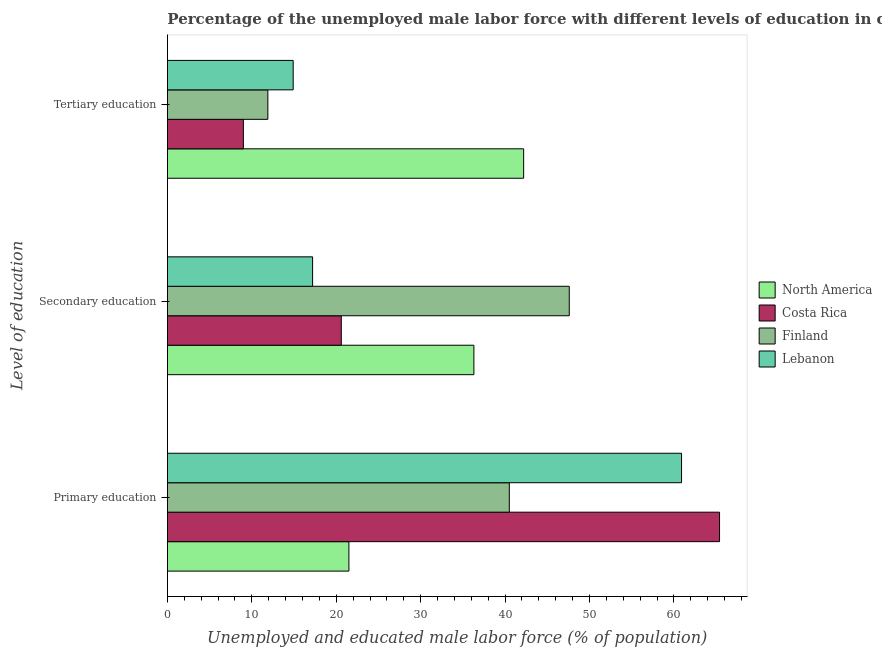Are the number of bars per tick equal to the number of legend labels?
Provide a succinct answer. Yes. Are the number of bars on each tick of the Y-axis equal?
Your response must be concise. Yes. What is the label of the 2nd group of bars from the top?
Provide a short and direct response. Secondary education. What is the percentage of male labor force who received primary education in Costa Rica?
Make the answer very short. 65.4. Across all countries, what is the maximum percentage of male labor force who received secondary education?
Offer a very short reply. 47.6. Across all countries, what is the minimum percentage of male labor force who received primary education?
Keep it short and to the point. 21.5. In which country was the percentage of male labor force who received secondary education maximum?
Give a very brief answer. Finland. In which country was the percentage of male labor force who received primary education minimum?
Offer a terse response. North America. What is the total percentage of male labor force who received secondary education in the graph?
Your answer should be very brief. 121.7. What is the difference between the percentage of male labor force who received tertiary education in North America and that in Costa Rica?
Your response must be concise. 33.2. What is the difference between the percentage of male labor force who received secondary education in Costa Rica and the percentage of male labor force who received primary education in North America?
Offer a terse response. -0.9. What is the average percentage of male labor force who received secondary education per country?
Keep it short and to the point. 30.43. What is the difference between the percentage of male labor force who received primary education and percentage of male labor force who received secondary education in Costa Rica?
Keep it short and to the point. 44.8. In how many countries, is the percentage of male labor force who received primary education greater than 60 %?
Provide a succinct answer. 2. What is the ratio of the percentage of male labor force who received tertiary education in North America to that in Finland?
Keep it short and to the point. 3.55. Is the percentage of male labor force who received tertiary education in Costa Rica less than that in Finland?
Your answer should be very brief. Yes. What is the difference between the highest and the second highest percentage of male labor force who received secondary education?
Ensure brevity in your answer.  11.3. What is the difference between the highest and the lowest percentage of male labor force who received primary education?
Offer a terse response. 43.9. In how many countries, is the percentage of male labor force who received secondary education greater than the average percentage of male labor force who received secondary education taken over all countries?
Give a very brief answer. 2. What does the 3rd bar from the top in Primary education represents?
Offer a terse response. Costa Rica. What does the 4th bar from the bottom in Primary education represents?
Offer a very short reply. Lebanon. Are all the bars in the graph horizontal?
Your answer should be compact. Yes. What is the difference between two consecutive major ticks on the X-axis?
Offer a very short reply. 10. Are the values on the major ticks of X-axis written in scientific E-notation?
Your response must be concise. No. Does the graph contain any zero values?
Provide a short and direct response. No. Does the graph contain grids?
Give a very brief answer. No. Where does the legend appear in the graph?
Your answer should be compact. Center right. How are the legend labels stacked?
Ensure brevity in your answer.  Vertical. What is the title of the graph?
Offer a very short reply. Percentage of the unemployed male labor force with different levels of education in countries. What is the label or title of the X-axis?
Make the answer very short. Unemployed and educated male labor force (% of population). What is the label or title of the Y-axis?
Provide a short and direct response. Level of education. What is the Unemployed and educated male labor force (% of population) in North America in Primary education?
Your answer should be compact. 21.5. What is the Unemployed and educated male labor force (% of population) of Costa Rica in Primary education?
Make the answer very short. 65.4. What is the Unemployed and educated male labor force (% of population) in Finland in Primary education?
Give a very brief answer. 40.5. What is the Unemployed and educated male labor force (% of population) of Lebanon in Primary education?
Your response must be concise. 60.9. What is the Unemployed and educated male labor force (% of population) in North America in Secondary education?
Offer a very short reply. 36.3. What is the Unemployed and educated male labor force (% of population) in Costa Rica in Secondary education?
Offer a very short reply. 20.6. What is the Unemployed and educated male labor force (% of population) of Finland in Secondary education?
Provide a succinct answer. 47.6. What is the Unemployed and educated male labor force (% of population) in Lebanon in Secondary education?
Ensure brevity in your answer.  17.2. What is the Unemployed and educated male labor force (% of population) in North America in Tertiary education?
Ensure brevity in your answer.  42.2. What is the Unemployed and educated male labor force (% of population) of Finland in Tertiary education?
Your answer should be very brief. 11.9. What is the Unemployed and educated male labor force (% of population) of Lebanon in Tertiary education?
Ensure brevity in your answer.  14.9. Across all Level of education, what is the maximum Unemployed and educated male labor force (% of population) in North America?
Your response must be concise. 42.2. Across all Level of education, what is the maximum Unemployed and educated male labor force (% of population) of Costa Rica?
Your answer should be compact. 65.4. Across all Level of education, what is the maximum Unemployed and educated male labor force (% of population) in Finland?
Make the answer very short. 47.6. Across all Level of education, what is the maximum Unemployed and educated male labor force (% of population) of Lebanon?
Provide a succinct answer. 60.9. Across all Level of education, what is the minimum Unemployed and educated male labor force (% of population) of North America?
Offer a very short reply. 21.5. Across all Level of education, what is the minimum Unemployed and educated male labor force (% of population) of Finland?
Give a very brief answer. 11.9. Across all Level of education, what is the minimum Unemployed and educated male labor force (% of population) in Lebanon?
Keep it short and to the point. 14.9. What is the total Unemployed and educated male labor force (% of population) in North America in the graph?
Keep it short and to the point. 100. What is the total Unemployed and educated male labor force (% of population) of Lebanon in the graph?
Provide a succinct answer. 93. What is the difference between the Unemployed and educated male labor force (% of population) in North America in Primary education and that in Secondary education?
Your answer should be compact. -14.8. What is the difference between the Unemployed and educated male labor force (% of population) in Costa Rica in Primary education and that in Secondary education?
Offer a terse response. 44.8. What is the difference between the Unemployed and educated male labor force (% of population) in Finland in Primary education and that in Secondary education?
Provide a short and direct response. -7.1. What is the difference between the Unemployed and educated male labor force (% of population) in Lebanon in Primary education and that in Secondary education?
Ensure brevity in your answer.  43.7. What is the difference between the Unemployed and educated male labor force (% of population) in North America in Primary education and that in Tertiary education?
Ensure brevity in your answer.  -20.7. What is the difference between the Unemployed and educated male labor force (% of population) of Costa Rica in Primary education and that in Tertiary education?
Provide a short and direct response. 56.4. What is the difference between the Unemployed and educated male labor force (% of population) of Finland in Primary education and that in Tertiary education?
Offer a very short reply. 28.6. What is the difference between the Unemployed and educated male labor force (% of population) of North America in Secondary education and that in Tertiary education?
Make the answer very short. -5.89. What is the difference between the Unemployed and educated male labor force (% of population) of Finland in Secondary education and that in Tertiary education?
Offer a very short reply. 35.7. What is the difference between the Unemployed and educated male labor force (% of population) of North America in Primary education and the Unemployed and educated male labor force (% of population) of Costa Rica in Secondary education?
Keep it short and to the point. 0.9. What is the difference between the Unemployed and educated male labor force (% of population) of North America in Primary education and the Unemployed and educated male labor force (% of population) of Finland in Secondary education?
Offer a very short reply. -26.1. What is the difference between the Unemployed and educated male labor force (% of population) of North America in Primary education and the Unemployed and educated male labor force (% of population) of Lebanon in Secondary education?
Ensure brevity in your answer.  4.3. What is the difference between the Unemployed and educated male labor force (% of population) of Costa Rica in Primary education and the Unemployed and educated male labor force (% of population) of Finland in Secondary education?
Give a very brief answer. 17.8. What is the difference between the Unemployed and educated male labor force (% of population) of Costa Rica in Primary education and the Unemployed and educated male labor force (% of population) of Lebanon in Secondary education?
Ensure brevity in your answer.  48.2. What is the difference between the Unemployed and educated male labor force (% of population) in Finland in Primary education and the Unemployed and educated male labor force (% of population) in Lebanon in Secondary education?
Provide a succinct answer. 23.3. What is the difference between the Unemployed and educated male labor force (% of population) of North America in Primary education and the Unemployed and educated male labor force (% of population) of Costa Rica in Tertiary education?
Your answer should be very brief. 12.5. What is the difference between the Unemployed and educated male labor force (% of population) of North America in Primary education and the Unemployed and educated male labor force (% of population) of Finland in Tertiary education?
Keep it short and to the point. 9.6. What is the difference between the Unemployed and educated male labor force (% of population) in North America in Primary education and the Unemployed and educated male labor force (% of population) in Lebanon in Tertiary education?
Offer a very short reply. 6.6. What is the difference between the Unemployed and educated male labor force (% of population) of Costa Rica in Primary education and the Unemployed and educated male labor force (% of population) of Finland in Tertiary education?
Provide a short and direct response. 53.5. What is the difference between the Unemployed and educated male labor force (% of population) of Costa Rica in Primary education and the Unemployed and educated male labor force (% of population) of Lebanon in Tertiary education?
Your response must be concise. 50.5. What is the difference between the Unemployed and educated male labor force (% of population) in Finland in Primary education and the Unemployed and educated male labor force (% of population) in Lebanon in Tertiary education?
Provide a succinct answer. 25.6. What is the difference between the Unemployed and educated male labor force (% of population) of North America in Secondary education and the Unemployed and educated male labor force (% of population) of Costa Rica in Tertiary education?
Provide a short and direct response. 27.3. What is the difference between the Unemployed and educated male labor force (% of population) of North America in Secondary education and the Unemployed and educated male labor force (% of population) of Finland in Tertiary education?
Your answer should be compact. 24.4. What is the difference between the Unemployed and educated male labor force (% of population) of North America in Secondary education and the Unemployed and educated male labor force (% of population) of Lebanon in Tertiary education?
Offer a terse response. 21.4. What is the difference between the Unemployed and educated male labor force (% of population) in Costa Rica in Secondary education and the Unemployed and educated male labor force (% of population) in Lebanon in Tertiary education?
Your answer should be very brief. 5.7. What is the difference between the Unemployed and educated male labor force (% of population) in Finland in Secondary education and the Unemployed and educated male labor force (% of population) in Lebanon in Tertiary education?
Offer a terse response. 32.7. What is the average Unemployed and educated male labor force (% of population) in North America per Level of education?
Ensure brevity in your answer.  33.33. What is the average Unemployed and educated male labor force (% of population) in Costa Rica per Level of education?
Your answer should be compact. 31.67. What is the average Unemployed and educated male labor force (% of population) in Finland per Level of education?
Provide a succinct answer. 33.33. What is the difference between the Unemployed and educated male labor force (% of population) of North America and Unemployed and educated male labor force (% of population) of Costa Rica in Primary education?
Your response must be concise. -43.9. What is the difference between the Unemployed and educated male labor force (% of population) of North America and Unemployed and educated male labor force (% of population) of Finland in Primary education?
Your answer should be very brief. -19. What is the difference between the Unemployed and educated male labor force (% of population) of North America and Unemployed and educated male labor force (% of population) of Lebanon in Primary education?
Give a very brief answer. -39.4. What is the difference between the Unemployed and educated male labor force (% of population) of Costa Rica and Unemployed and educated male labor force (% of population) of Finland in Primary education?
Make the answer very short. 24.9. What is the difference between the Unemployed and educated male labor force (% of population) of Finland and Unemployed and educated male labor force (% of population) of Lebanon in Primary education?
Offer a terse response. -20.4. What is the difference between the Unemployed and educated male labor force (% of population) in North America and Unemployed and educated male labor force (% of population) in Costa Rica in Secondary education?
Your answer should be very brief. 15.7. What is the difference between the Unemployed and educated male labor force (% of population) in North America and Unemployed and educated male labor force (% of population) in Finland in Secondary education?
Provide a succinct answer. -11.3. What is the difference between the Unemployed and educated male labor force (% of population) in North America and Unemployed and educated male labor force (% of population) in Lebanon in Secondary education?
Provide a succinct answer. 19.1. What is the difference between the Unemployed and educated male labor force (% of population) in Costa Rica and Unemployed and educated male labor force (% of population) in Finland in Secondary education?
Provide a succinct answer. -27. What is the difference between the Unemployed and educated male labor force (% of population) in Finland and Unemployed and educated male labor force (% of population) in Lebanon in Secondary education?
Offer a very short reply. 30.4. What is the difference between the Unemployed and educated male labor force (% of population) in North America and Unemployed and educated male labor force (% of population) in Costa Rica in Tertiary education?
Give a very brief answer. 33.2. What is the difference between the Unemployed and educated male labor force (% of population) in North America and Unemployed and educated male labor force (% of population) in Finland in Tertiary education?
Make the answer very short. 30.3. What is the difference between the Unemployed and educated male labor force (% of population) in North America and Unemployed and educated male labor force (% of population) in Lebanon in Tertiary education?
Make the answer very short. 27.3. What is the difference between the Unemployed and educated male labor force (% of population) of Costa Rica and Unemployed and educated male labor force (% of population) of Finland in Tertiary education?
Provide a short and direct response. -2.9. What is the ratio of the Unemployed and educated male labor force (% of population) in North America in Primary education to that in Secondary education?
Make the answer very short. 0.59. What is the ratio of the Unemployed and educated male labor force (% of population) in Costa Rica in Primary education to that in Secondary education?
Give a very brief answer. 3.17. What is the ratio of the Unemployed and educated male labor force (% of population) of Finland in Primary education to that in Secondary education?
Your answer should be very brief. 0.85. What is the ratio of the Unemployed and educated male labor force (% of population) of Lebanon in Primary education to that in Secondary education?
Provide a succinct answer. 3.54. What is the ratio of the Unemployed and educated male labor force (% of population) in North America in Primary education to that in Tertiary education?
Provide a succinct answer. 0.51. What is the ratio of the Unemployed and educated male labor force (% of population) in Costa Rica in Primary education to that in Tertiary education?
Your response must be concise. 7.27. What is the ratio of the Unemployed and educated male labor force (% of population) of Finland in Primary education to that in Tertiary education?
Offer a terse response. 3.4. What is the ratio of the Unemployed and educated male labor force (% of population) in Lebanon in Primary education to that in Tertiary education?
Offer a terse response. 4.09. What is the ratio of the Unemployed and educated male labor force (% of population) of North America in Secondary education to that in Tertiary education?
Provide a succinct answer. 0.86. What is the ratio of the Unemployed and educated male labor force (% of population) of Costa Rica in Secondary education to that in Tertiary education?
Give a very brief answer. 2.29. What is the ratio of the Unemployed and educated male labor force (% of population) of Finland in Secondary education to that in Tertiary education?
Offer a very short reply. 4. What is the ratio of the Unemployed and educated male labor force (% of population) in Lebanon in Secondary education to that in Tertiary education?
Offer a terse response. 1.15. What is the difference between the highest and the second highest Unemployed and educated male labor force (% of population) of North America?
Ensure brevity in your answer.  5.89. What is the difference between the highest and the second highest Unemployed and educated male labor force (% of population) in Costa Rica?
Offer a very short reply. 44.8. What is the difference between the highest and the second highest Unemployed and educated male labor force (% of population) of Lebanon?
Make the answer very short. 43.7. What is the difference between the highest and the lowest Unemployed and educated male labor force (% of population) of North America?
Your answer should be compact. 20.7. What is the difference between the highest and the lowest Unemployed and educated male labor force (% of population) in Costa Rica?
Your answer should be very brief. 56.4. What is the difference between the highest and the lowest Unemployed and educated male labor force (% of population) in Finland?
Your answer should be compact. 35.7. What is the difference between the highest and the lowest Unemployed and educated male labor force (% of population) of Lebanon?
Ensure brevity in your answer.  46. 